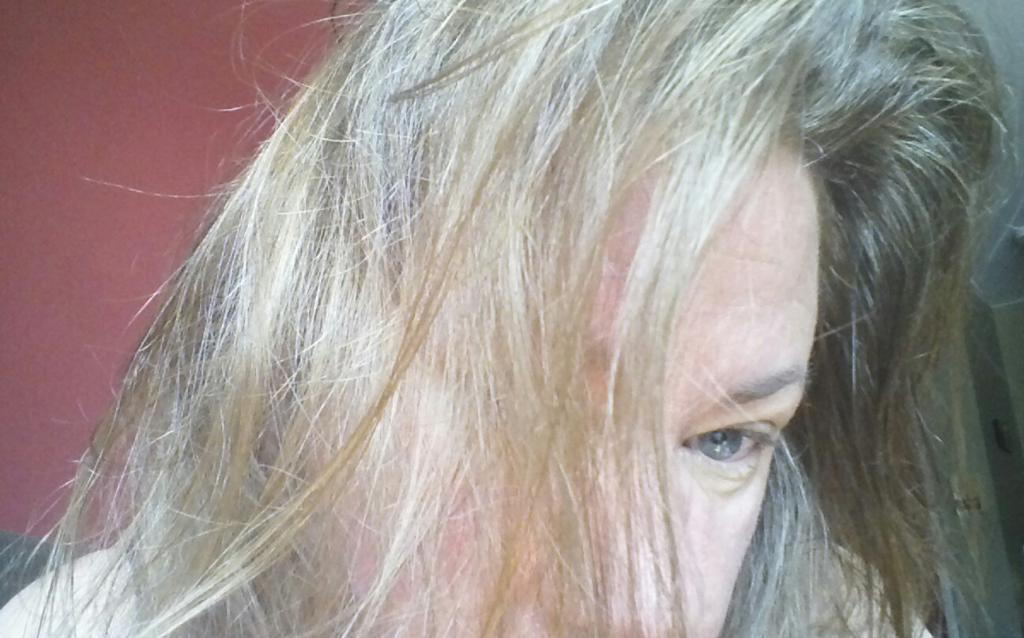What is the main subject of subject of the image? There is a person in the image. Can you describe the person's hair? The person has black and white hair. What color is the background of the image? The background of the image is maroon in color. What type of fruit is the person holding in the image? There is no fruit present in the image. How many clams are visible on the person's clothing in the image? There are no clams visible on the person's clothing in the image. 